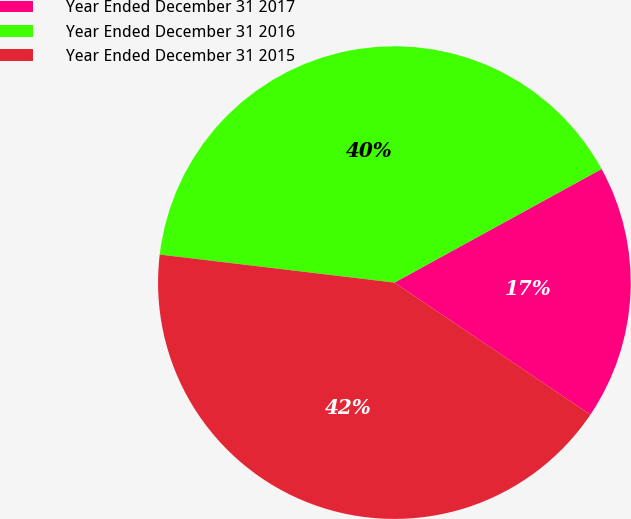<chart> <loc_0><loc_0><loc_500><loc_500><pie_chart><fcel>Year Ended December 31 2017<fcel>Year Ended December 31 2016<fcel>Year Ended December 31 2015<nl><fcel>17.42%<fcel>40.13%<fcel>42.46%<nl></chart> 